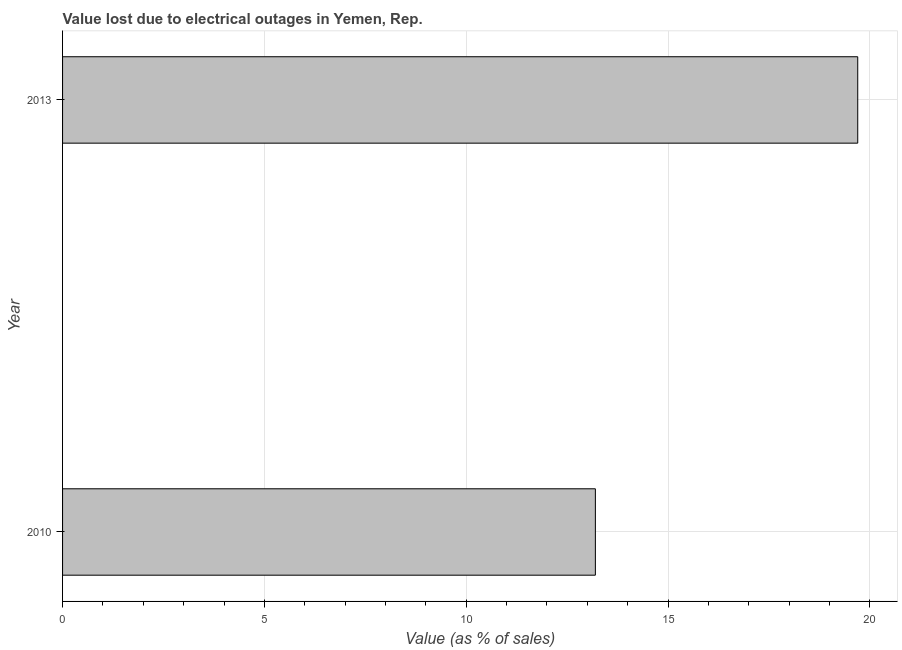Does the graph contain grids?
Your response must be concise. Yes. What is the title of the graph?
Provide a short and direct response. Value lost due to electrical outages in Yemen, Rep. What is the label or title of the X-axis?
Your answer should be compact. Value (as % of sales). What is the label or title of the Y-axis?
Offer a terse response. Year. What is the value lost due to electrical outages in 2013?
Provide a short and direct response. 19.7. Across all years, what is the minimum value lost due to electrical outages?
Offer a very short reply. 13.2. What is the sum of the value lost due to electrical outages?
Keep it short and to the point. 32.9. What is the difference between the value lost due to electrical outages in 2010 and 2013?
Keep it short and to the point. -6.5. What is the average value lost due to electrical outages per year?
Your response must be concise. 16.45. What is the median value lost due to electrical outages?
Provide a succinct answer. 16.45. What is the ratio of the value lost due to electrical outages in 2010 to that in 2013?
Offer a very short reply. 0.67. What is the difference between two consecutive major ticks on the X-axis?
Provide a succinct answer. 5. What is the Value (as % of sales) in 2013?
Give a very brief answer. 19.7. What is the ratio of the Value (as % of sales) in 2010 to that in 2013?
Your response must be concise. 0.67. 